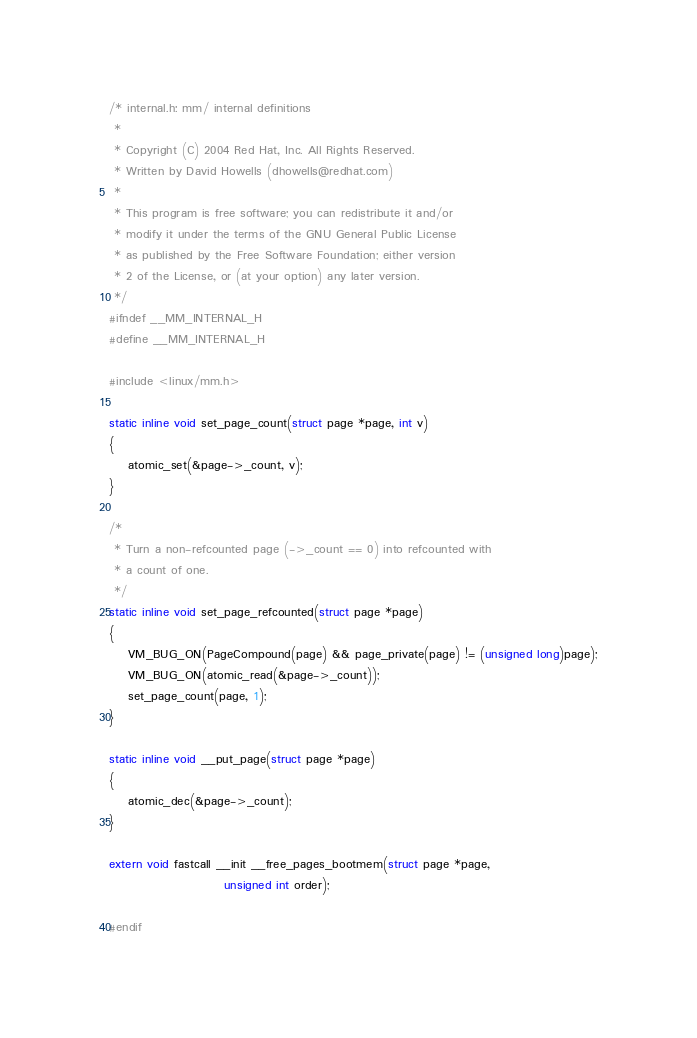<code> <loc_0><loc_0><loc_500><loc_500><_C_>/* internal.h: mm/ internal definitions
 *
 * Copyright (C) 2004 Red Hat, Inc. All Rights Reserved.
 * Written by David Howells (dhowells@redhat.com)
 *
 * This program is free software; you can redistribute it and/or
 * modify it under the terms of the GNU General Public License
 * as published by the Free Software Foundation; either version
 * 2 of the License, or (at your option) any later version.
 */
#ifndef __MM_INTERNAL_H
#define __MM_INTERNAL_H

#include <linux/mm.h>

static inline void set_page_count(struct page *page, int v)
{
	atomic_set(&page->_count, v);
}

/*
 * Turn a non-refcounted page (->_count == 0) into refcounted with
 * a count of one.
 */
static inline void set_page_refcounted(struct page *page)
{
	VM_BUG_ON(PageCompound(page) && page_private(page) != (unsigned long)page);
	VM_BUG_ON(atomic_read(&page->_count));
	set_page_count(page, 1);
}

static inline void __put_page(struct page *page)
{
	atomic_dec(&page->_count);
}

extern void fastcall __init __free_pages_bootmem(struct page *page,
						unsigned int order);

#endif
</code> 